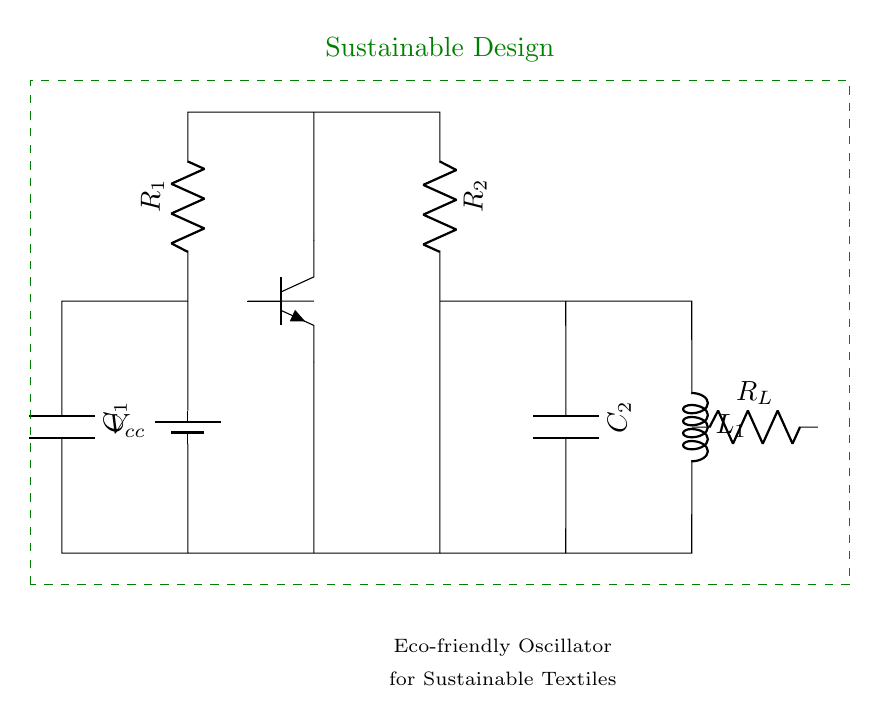What is the component labeled R1? R1 is a resistor that provides resistance in the circuit, controlling the current flow. Its position at the top indicates that it is connected to the positive terminal of the battery and is a part of the oscillator's timing circuit.
Answer: Resistor What type of circuit is this? The diagram represents an oscillator circuit designed to generate low-frequency vibrations, suitable for sustainable textile manufacturing through eco-friendly practices.
Answer: Oscillator What is the role of capacitor C1? C1 serves to store and release energy within the oscillator circuit. It affects the timing characteristics of the oscillation cycle, contributing to the frequency at which the circuit operates.
Answer: Energy storage How many resistors are present in the circuit? There are two resistors shown in the circuit: R1 and R2. Each performs a distinct function in controlling current and contributing to the oscillator's behavior.
Answer: Two What does the inductor L1 do in this circuit? L1 functions to store energy in a magnetic field when electrical current passes through it. In the context of an oscillator, it helps determine the frequency of the oscillation alongside capacitors.
Answer: Energy storage What does the label R_L indicate? R_L indicates the load resistor, which is connected to the output side of the oscillator. Its purpose is to control the current flow to the load that the oscillator powers.
Answer: Load resistor 